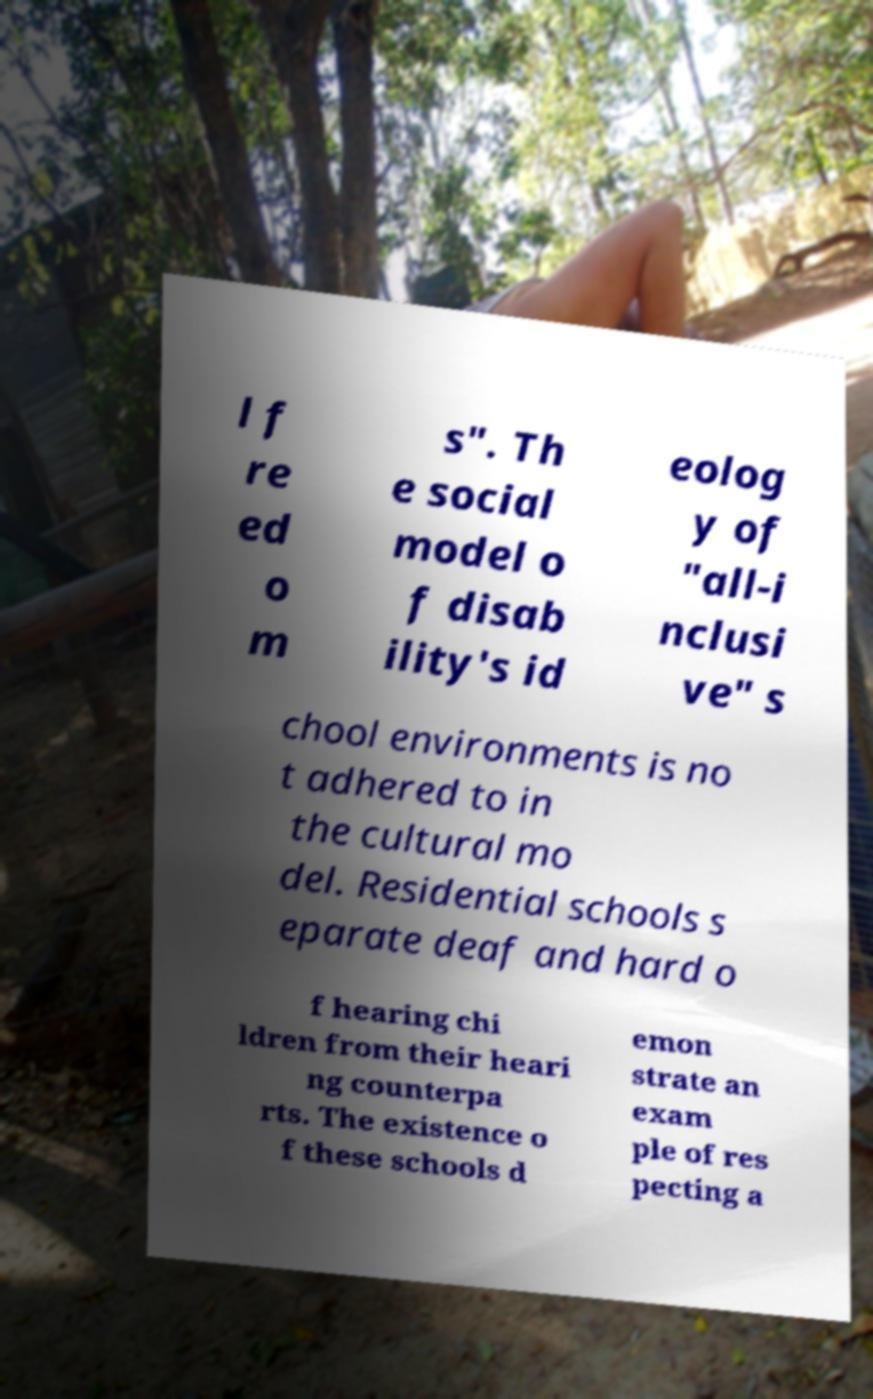Could you extract and type out the text from this image? l f re ed o m s". Th e social model o f disab ility's id eolog y of "all-i nclusi ve" s chool environments is no t adhered to in the cultural mo del. Residential schools s eparate deaf and hard o f hearing chi ldren from their heari ng counterpa rts. The existence o f these schools d emon strate an exam ple of res pecting a 